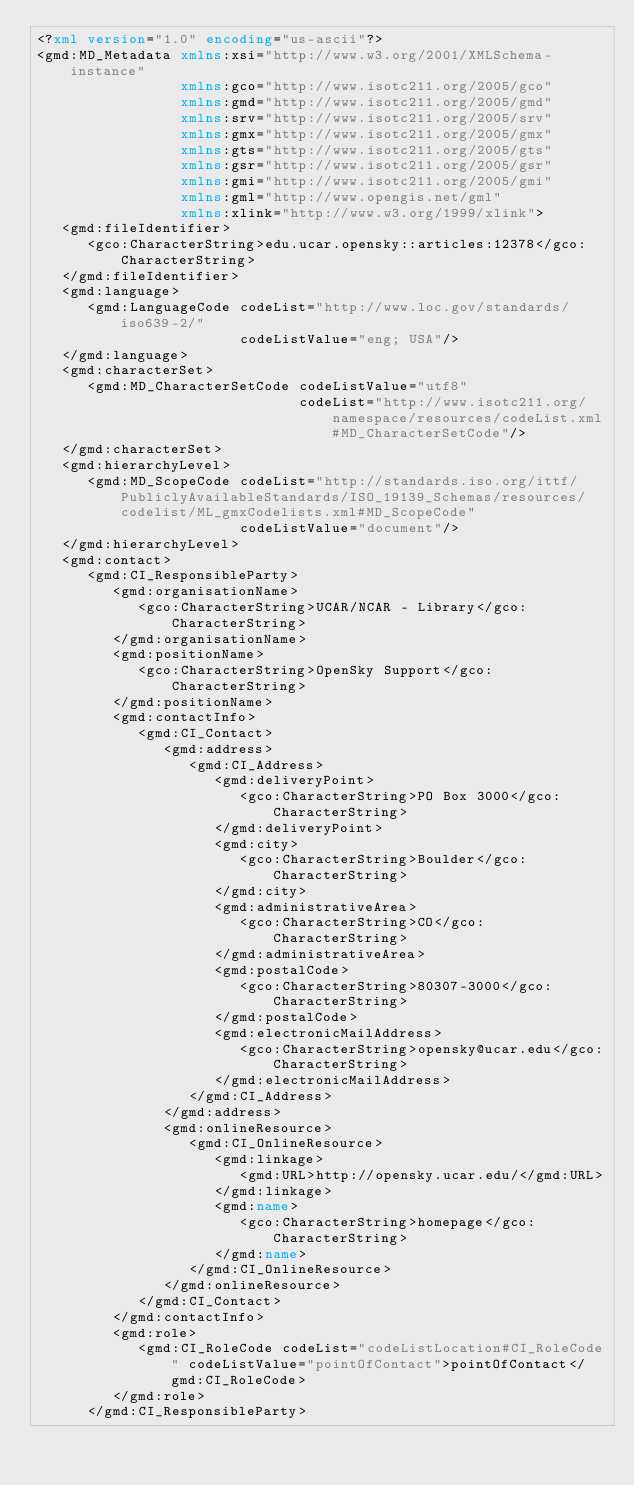Convert code to text. <code><loc_0><loc_0><loc_500><loc_500><_XML_><?xml version="1.0" encoding="us-ascii"?>
<gmd:MD_Metadata xmlns:xsi="http://www.w3.org/2001/XMLSchema-instance"
                 xmlns:gco="http://www.isotc211.org/2005/gco"
                 xmlns:gmd="http://www.isotc211.org/2005/gmd"
                 xmlns:srv="http://www.isotc211.org/2005/srv"
                 xmlns:gmx="http://www.isotc211.org/2005/gmx"
                 xmlns:gts="http://www.isotc211.org/2005/gts"
                 xmlns:gsr="http://www.isotc211.org/2005/gsr"
                 xmlns:gmi="http://www.isotc211.org/2005/gmi"
                 xmlns:gml="http://www.opengis.net/gml"
                 xmlns:xlink="http://www.w3.org/1999/xlink">
   <gmd:fileIdentifier>
      <gco:CharacterString>edu.ucar.opensky::articles:12378</gco:CharacterString>
   </gmd:fileIdentifier>
   <gmd:language>
      <gmd:LanguageCode codeList="http://www.loc.gov/standards/iso639-2/"
                        codeListValue="eng; USA"/>
   </gmd:language>
   <gmd:characterSet>
      <gmd:MD_CharacterSetCode codeListValue="utf8"
                               codeList="http://www.isotc211.org/namespace/resources/codeList.xml#MD_CharacterSetCode"/>
   </gmd:characterSet>
   <gmd:hierarchyLevel>
      <gmd:MD_ScopeCode codeList="http://standards.iso.org/ittf/PubliclyAvailableStandards/ISO_19139_Schemas/resources/codelist/ML_gmxCodelists.xml#MD_ScopeCode"
                        codeListValue="document"/>
   </gmd:hierarchyLevel>
   <gmd:contact>
      <gmd:CI_ResponsibleParty>
         <gmd:organisationName>
            <gco:CharacterString>UCAR/NCAR - Library</gco:CharacterString>
         </gmd:organisationName>
         <gmd:positionName>
            <gco:CharacterString>OpenSky Support</gco:CharacterString>
         </gmd:positionName>
         <gmd:contactInfo>
            <gmd:CI_Contact>
               <gmd:address>
                  <gmd:CI_Address>
                     <gmd:deliveryPoint>
                        <gco:CharacterString>PO Box 3000</gco:CharacterString>
                     </gmd:deliveryPoint>
                     <gmd:city>
                        <gco:CharacterString>Boulder</gco:CharacterString>
                     </gmd:city>
                     <gmd:administrativeArea>
                        <gco:CharacterString>CO</gco:CharacterString>
                     </gmd:administrativeArea>
                     <gmd:postalCode>
                        <gco:CharacterString>80307-3000</gco:CharacterString>
                     </gmd:postalCode>
                     <gmd:electronicMailAddress>
                        <gco:CharacterString>opensky@ucar.edu</gco:CharacterString>
                     </gmd:electronicMailAddress>
                  </gmd:CI_Address>
               </gmd:address>
               <gmd:onlineResource>
                  <gmd:CI_OnlineResource>
                     <gmd:linkage>
                        <gmd:URL>http://opensky.ucar.edu/</gmd:URL>
                     </gmd:linkage>
                     <gmd:name>
                        <gco:CharacterString>homepage</gco:CharacterString>
                     </gmd:name>
                  </gmd:CI_OnlineResource>
               </gmd:onlineResource>
            </gmd:CI_Contact>
         </gmd:contactInfo>
         <gmd:role>
            <gmd:CI_RoleCode codeList="codeListLocation#CI_RoleCode" codeListValue="pointOfContact">pointOfContact</gmd:CI_RoleCode>
         </gmd:role>
      </gmd:CI_ResponsibleParty></code> 